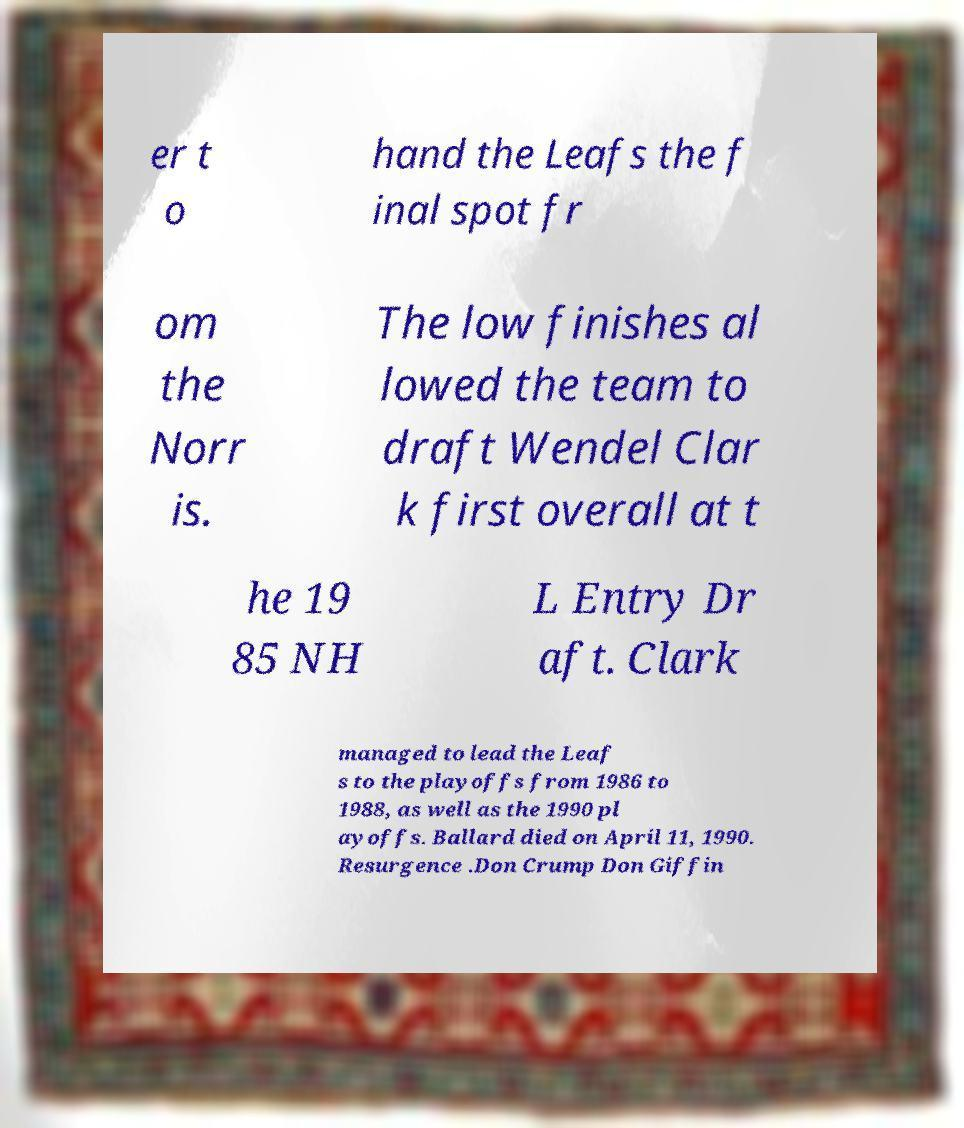I need the written content from this picture converted into text. Can you do that? er t o hand the Leafs the f inal spot fr om the Norr is. The low finishes al lowed the team to draft Wendel Clar k first overall at t he 19 85 NH L Entry Dr aft. Clark managed to lead the Leaf s to the playoffs from 1986 to 1988, as well as the 1990 pl ayoffs. Ballard died on April 11, 1990. Resurgence .Don Crump Don Giffin 